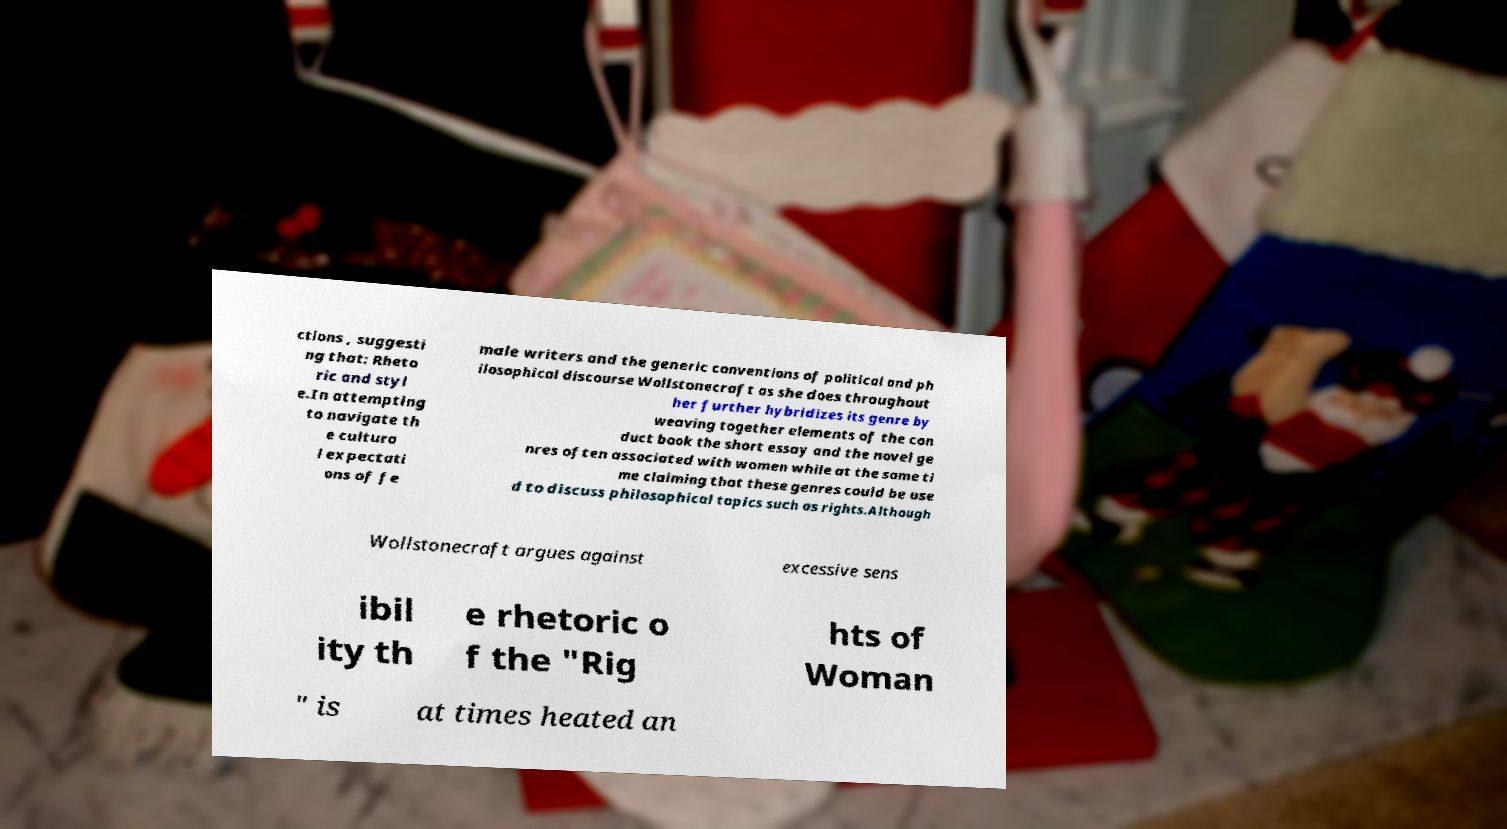Please read and relay the text visible in this image. What does it say? ctions , suggesti ng that: Rheto ric and styl e.In attempting to navigate th e cultura l expectati ons of fe male writers and the generic conventions of political and ph ilosophical discourse Wollstonecraft as she does throughout her further hybridizes its genre by weaving together elements of the con duct book the short essay and the novel ge nres often associated with women while at the same ti me claiming that these genres could be use d to discuss philosophical topics such as rights.Although Wollstonecraft argues against excessive sens ibil ity th e rhetoric o f the "Rig hts of Woman " is at times heated an 